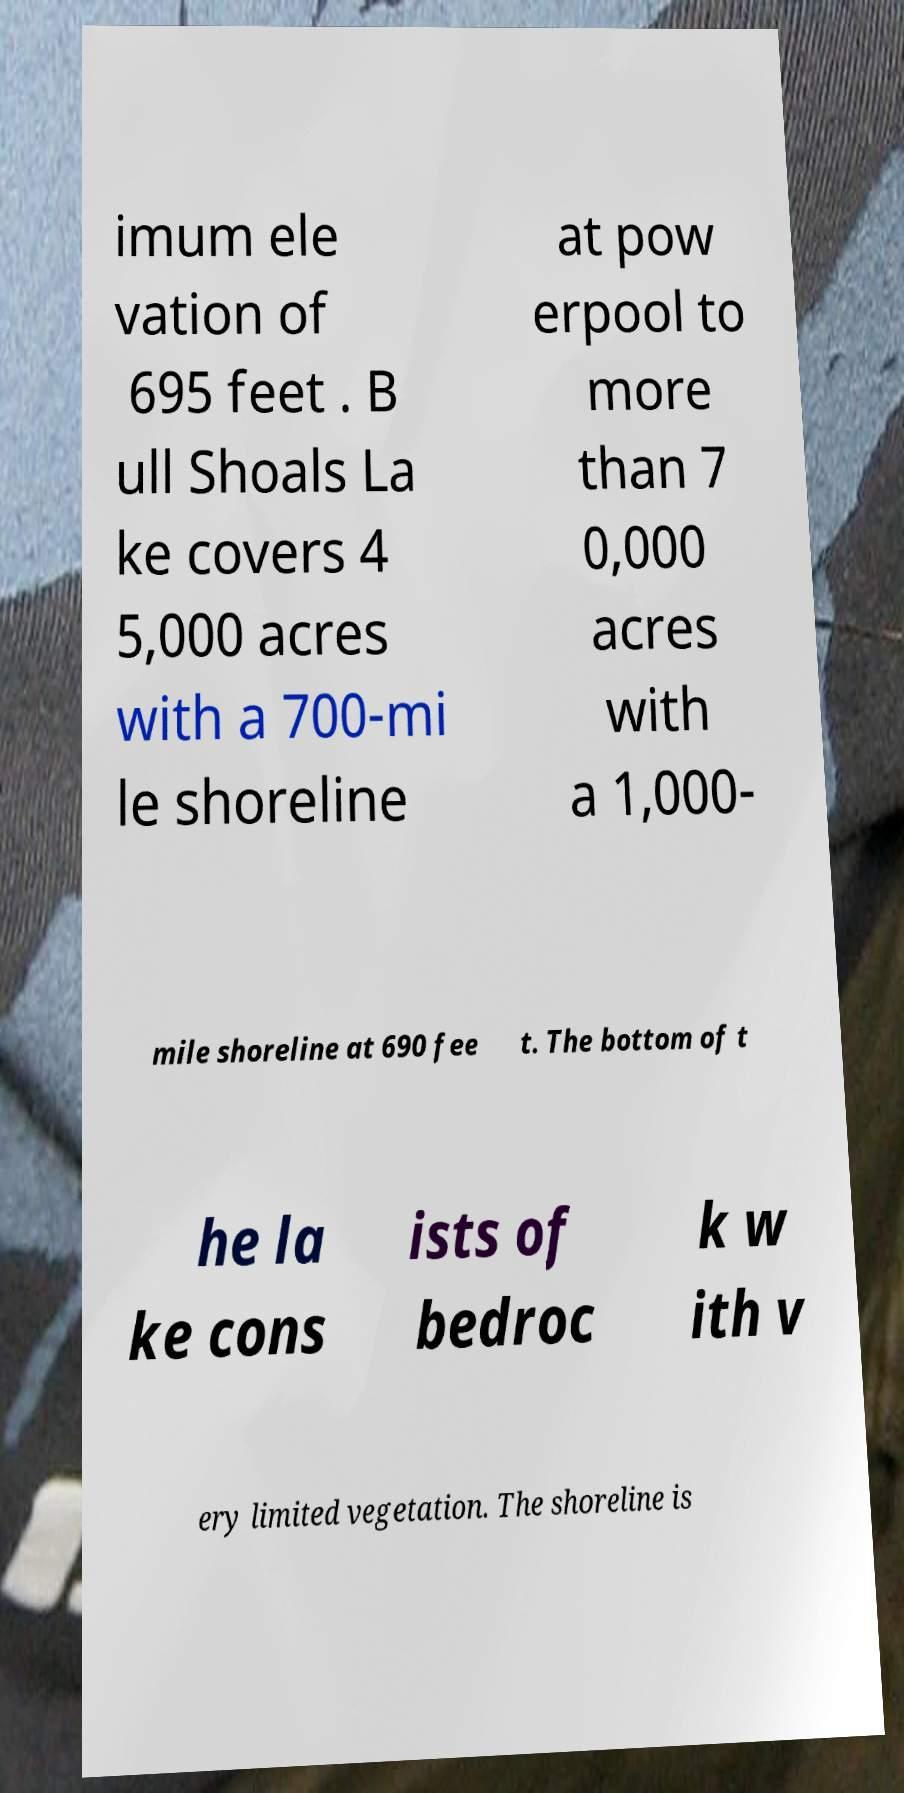There's text embedded in this image that I need extracted. Can you transcribe it verbatim? imum ele vation of 695 feet . B ull Shoals La ke covers 4 5,000 acres with a 700-mi le shoreline at pow erpool to more than 7 0,000 acres with a 1,000- mile shoreline at 690 fee t. The bottom of t he la ke cons ists of bedroc k w ith v ery limited vegetation. The shoreline is 